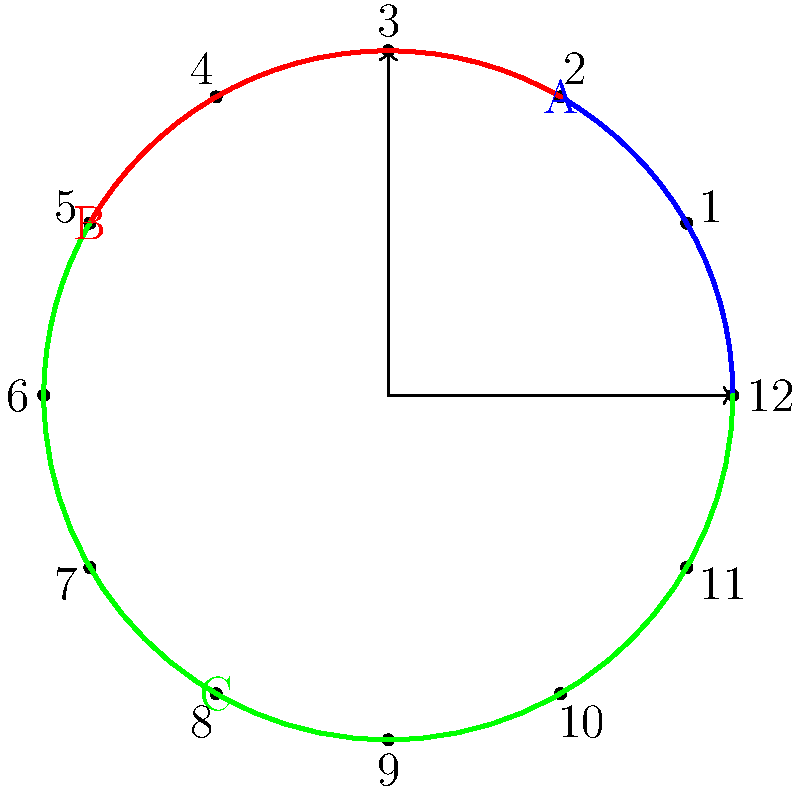As a social media influencer, you're helping your introverted friend plan their YouTube upload schedule. The circular clock diagram represents a 24-hour day, divided into three segments: A (blue), B (red), and C (green). Segment A spans from 12 AM to 4 AM, segment B from 4 AM to 10 AM, and segment C from 10 AM to 12 AM. If your friend wants to upload during the time with the largest angle, which segment should they choose, and what is the central angle of that segment in degrees? To determine the best upload schedule, we need to calculate the central angle for each segment and compare them:

1. Segment A (blue):
   - Spans from 12 AM to 4 AM
   - Time duration: 4 hours
   - Angle calculation: $\frac{4}{24} \times 360° = 60°$

2. Segment B (red):
   - Spans from 4 AM to 10 AM
   - Time duration: 6 hours
   - Angle calculation: $\frac{6}{24} \times 360° = 90°$

3. Segment C (green):
   - Spans from 10 AM to 12 AM
   - Time duration: 14 hours
   - Angle calculation: $\frac{14}{24} \times 360° = 210°$

Comparing the central angles:
- Segment A: 60°
- Segment B: 90°
- Segment C: 210°

Segment C has the largest central angle of 210°.

Therefore, your friend should choose to upload during segment C (from 10 AM to 12 AM) to maximize their potential audience reach.
Answer: Segment C, 210° 